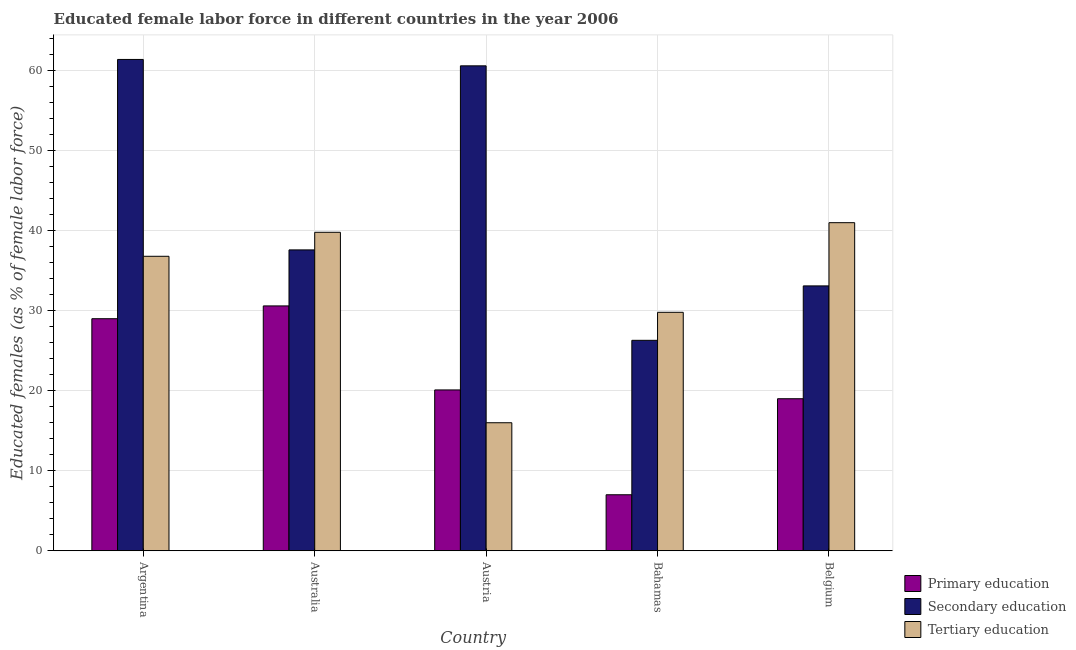How many different coloured bars are there?
Offer a very short reply. 3. Are the number of bars per tick equal to the number of legend labels?
Your answer should be compact. Yes. Are the number of bars on each tick of the X-axis equal?
Provide a short and direct response. Yes. How many bars are there on the 3rd tick from the left?
Your response must be concise. 3. How many bars are there on the 4th tick from the right?
Provide a short and direct response. 3. What is the label of the 5th group of bars from the left?
Provide a short and direct response. Belgium. In how many cases, is the number of bars for a given country not equal to the number of legend labels?
Your answer should be compact. 0. What is the percentage of female labor force who received primary education in Belgium?
Your answer should be compact. 19. Across all countries, what is the minimum percentage of female labor force who received tertiary education?
Provide a succinct answer. 16. In which country was the percentage of female labor force who received primary education maximum?
Make the answer very short. Australia. In which country was the percentage of female labor force who received secondary education minimum?
Provide a succinct answer. Bahamas. What is the total percentage of female labor force who received tertiary education in the graph?
Your answer should be very brief. 163.4. What is the difference between the percentage of female labor force who received secondary education in Bahamas and that in Belgium?
Keep it short and to the point. -6.8. What is the difference between the percentage of female labor force who received tertiary education in Bahamas and the percentage of female labor force who received primary education in Austria?
Provide a short and direct response. 9.7. What is the average percentage of female labor force who received tertiary education per country?
Provide a short and direct response. 32.68. What is the difference between the percentage of female labor force who received primary education and percentage of female labor force who received tertiary education in Argentina?
Your answer should be compact. -7.8. In how many countries, is the percentage of female labor force who received secondary education greater than 46 %?
Keep it short and to the point. 2. What is the ratio of the percentage of female labor force who received secondary education in Argentina to that in Austria?
Your answer should be very brief. 1.01. What is the difference between the highest and the second highest percentage of female labor force who received primary education?
Ensure brevity in your answer.  1.6. What is the difference between the highest and the lowest percentage of female labor force who received secondary education?
Make the answer very short. 35.1. Is the sum of the percentage of female labor force who received tertiary education in Austria and Belgium greater than the maximum percentage of female labor force who received secondary education across all countries?
Provide a short and direct response. No. How many bars are there?
Keep it short and to the point. 15. How many countries are there in the graph?
Ensure brevity in your answer.  5. Are the values on the major ticks of Y-axis written in scientific E-notation?
Offer a very short reply. No. Does the graph contain grids?
Keep it short and to the point. Yes. Where does the legend appear in the graph?
Give a very brief answer. Bottom right. How are the legend labels stacked?
Offer a very short reply. Vertical. What is the title of the graph?
Ensure brevity in your answer.  Educated female labor force in different countries in the year 2006. Does "Poland" appear as one of the legend labels in the graph?
Your answer should be compact. No. What is the label or title of the Y-axis?
Provide a succinct answer. Educated females (as % of female labor force). What is the Educated females (as % of female labor force) of Primary education in Argentina?
Your answer should be very brief. 29. What is the Educated females (as % of female labor force) in Secondary education in Argentina?
Offer a very short reply. 61.4. What is the Educated females (as % of female labor force) in Tertiary education in Argentina?
Keep it short and to the point. 36.8. What is the Educated females (as % of female labor force) in Primary education in Australia?
Provide a succinct answer. 30.6. What is the Educated females (as % of female labor force) in Secondary education in Australia?
Your response must be concise. 37.6. What is the Educated females (as % of female labor force) of Tertiary education in Australia?
Make the answer very short. 39.8. What is the Educated females (as % of female labor force) of Primary education in Austria?
Offer a very short reply. 20.1. What is the Educated females (as % of female labor force) of Secondary education in Austria?
Keep it short and to the point. 60.6. What is the Educated females (as % of female labor force) of Secondary education in Bahamas?
Keep it short and to the point. 26.3. What is the Educated females (as % of female labor force) of Tertiary education in Bahamas?
Provide a short and direct response. 29.8. What is the Educated females (as % of female labor force) in Primary education in Belgium?
Provide a succinct answer. 19. What is the Educated females (as % of female labor force) in Secondary education in Belgium?
Provide a short and direct response. 33.1. Across all countries, what is the maximum Educated females (as % of female labor force) of Primary education?
Your answer should be compact. 30.6. Across all countries, what is the maximum Educated females (as % of female labor force) of Secondary education?
Offer a terse response. 61.4. Across all countries, what is the maximum Educated females (as % of female labor force) of Tertiary education?
Give a very brief answer. 41. Across all countries, what is the minimum Educated females (as % of female labor force) of Secondary education?
Provide a short and direct response. 26.3. Across all countries, what is the minimum Educated females (as % of female labor force) in Tertiary education?
Offer a terse response. 16. What is the total Educated females (as % of female labor force) in Primary education in the graph?
Keep it short and to the point. 105.7. What is the total Educated females (as % of female labor force) of Secondary education in the graph?
Ensure brevity in your answer.  219. What is the total Educated females (as % of female labor force) in Tertiary education in the graph?
Keep it short and to the point. 163.4. What is the difference between the Educated females (as % of female labor force) in Primary education in Argentina and that in Australia?
Make the answer very short. -1.6. What is the difference between the Educated females (as % of female labor force) in Secondary education in Argentina and that in Australia?
Your answer should be very brief. 23.8. What is the difference between the Educated females (as % of female labor force) of Primary education in Argentina and that in Austria?
Make the answer very short. 8.9. What is the difference between the Educated females (as % of female labor force) in Secondary education in Argentina and that in Austria?
Ensure brevity in your answer.  0.8. What is the difference between the Educated females (as % of female labor force) of Tertiary education in Argentina and that in Austria?
Offer a very short reply. 20.8. What is the difference between the Educated females (as % of female labor force) of Secondary education in Argentina and that in Bahamas?
Your answer should be very brief. 35.1. What is the difference between the Educated females (as % of female labor force) of Tertiary education in Argentina and that in Bahamas?
Provide a short and direct response. 7. What is the difference between the Educated females (as % of female labor force) of Secondary education in Argentina and that in Belgium?
Your answer should be compact. 28.3. What is the difference between the Educated females (as % of female labor force) in Primary education in Australia and that in Austria?
Give a very brief answer. 10.5. What is the difference between the Educated females (as % of female labor force) in Secondary education in Australia and that in Austria?
Make the answer very short. -23. What is the difference between the Educated females (as % of female labor force) in Tertiary education in Australia and that in Austria?
Ensure brevity in your answer.  23.8. What is the difference between the Educated females (as % of female labor force) of Primary education in Australia and that in Bahamas?
Provide a short and direct response. 23.6. What is the difference between the Educated females (as % of female labor force) of Secondary education in Australia and that in Bahamas?
Provide a short and direct response. 11.3. What is the difference between the Educated females (as % of female labor force) in Tertiary education in Australia and that in Bahamas?
Give a very brief answer. 10. What is the difference between the Educated females (as % of female labor force) of Secondary education in Austria and that in Bahamas?
Offer a very short reply. 34.3. What is the difference between the Educated females (as % of female labor force) in Primary education in Austria and that in Belgium?
Keep it short and to the point. 1.1. What is the difference between the Educated females (as % of female labor force) of Tertiary education in Austria and that in Belgium?
Offer a terse response. -25. What is the difference between the Educated females (as % of female labor force) in Secondary education in Bahamas and that in Belgium?
Provide a succinct answer. -6.8. What is the difference between the Educated females (as % of female labor force) in Primary education in Argentina and the Educated females (as % of female labor force) in Secondary education in Australia?
Offer a very short reply. -8.6. What is the difference between the Educated females (as % of female labor force) of Primary education in Argentina and the Educated females (as % of female labor force) of Tertiary education in Australia?
Offer a terse response. -10.8. What is the difference between the Educated females (as % of female labor force) in Secondary education in Argentina and the Educated females (as % of female labor force) in Tertiary education in Australia?
Offer a very short reply. 21.6. What is the difference between the Educated females (as % of female labor force) of Primary education in Argentina and the Educated females (as % of female labor force) of Secondary education in Austria?
Give a very brief answer. -31.6. What is the difference between the Educated females (as % of female labor force) in Primary education in Argentina and the Educated females (as % of female labor force) in Tertiary education in Austria?
Keep it short and to the point. 13. What is the difference between the Educated females (as % of female labor force) in Secondary education in Argentina and the Educated females (as % of female labor force) in Tertiary education in Austria?
Make the answer very short. 45.4. What is the difference between the Educated females (as % of female labor force) of Primary education in Argentina and the Educated females (as % of female labor force) of Secondary education in Bahamas?
Offer a terse response. 2.7. What is the difference between the Educated females (as % of female labor force) in Primary education in Argentina and the Educated females (as % of female labor force) in Tertiary education in Bahamas?
Give a very brief answer. -0.8. What is the difference between the Educated females (as % of female labor force) of Secondary education in Argentina and the Educated females (as % of female labor force) of Tertiary education in Bahamas?
Your answer should be compact. 31.6. What is the difference between the Educated females (as % of female labor force) in Primary education in Argentina and the Educated females (as % of female labor force) in Secondary education in Belgium?
Give a very brief answer. -4.1. What is the difference between the Educated females (as % of female labor force) in Secondary education in Argentina and the Educated females (as % of female labor force) in Tertiary education in Belgium?
Provide a succinct answer. 20.4. What is the difference between the Educated females (as % of female labor force) of Secondary education in Australia and the Educated females (as % of female labor force) of Tertiary education in Austria?
Offer a very short reply. 21.6. What is the difference between the Educated females (as % of female labor force) in Primary education in Australia and the Educated females (as % of female labor force) in Secondary education in Bahamas?
Offer a terse response. 4.3. What is the difference between the Educated females (as % of female labor force) in Primary education in Australia and the Educated females (as % of female labor force) in Tertiary education in Belgium?
Your answer should be compact. -10.4. What is the difference between the Educated females (as % of female labor force) in Secondary education in Australia and the Educated females (as % of female labor force) in Tertiary education in Belgium?
Give a very brief answer. -3.4. What is the difference between the Educated females (as % of female labor force) of Secondary education in Austria and the Educated females (as % of female labor force) of Tertiary education in Bahamas?
Your answer should be very brief. 30.8. What is the difference between the Educated females (as % of female labor force) in Primary education in Austria and the Educated females (as % of female labor force) in Tertiary education in Belgium?
Ensure brevity in your answer.  -20.9. What is the difference between the Educated females (as % of female labor force) in Secondary education in Austria and the Educated females (as % of female labor force) in Tertiary education in Belgium?
Make the answer very short. 19.6. What is the difference between the Educated females (as % of female labor force) in Primary education in Bahamas and the Educated females (as % of female labor force) in Secondary education in Belgium?
Your answer should be compact. -26.1. What is the difference between the Educated females (as % of female labor force) in Primary education in Bahamas and the Educated females (as % of female labor force) in Tertiary education in Belgium?
Your answer should be compact. -34. What is the difference between the Educated females (as % of female labor force) of Secondary education in Bahamas and the Educated females (as % of female labor force) of Tertiary education in Belgium?
Your answer should be very brief. -14.7. What is the average Educated females (as % of female labor force) in Primary education per country?
Offer a terse response. 21.14. What is the average Educated females (as % of female labor force) of Secondary education per country?
Your answer should be very brief. 43.8. What is the average Educated females (as % of female labor force) in Tertiary education per country?
Your answer should be very brief. 32.68. What is the difference between the Educated females (as % of female labor force) in Primary education and Educated females (as % of female labor force) in Secondary education in Argentina?
Your response must be concise. -32.4. What is the difference between the Educated females (as % of female labor force) of Secondary education and Educated females (as % of female labor force) of Tertiary education in Argentina?
Provide a short and direct response. 24.6. What is the difference between the Educated females (as % of female labor force) of Primary education and Educated females (as % of female labor force) of Tertiary education in Australia?
Ensure brevity in your answer.  -9.2. What is the difference between the Educated females (as % of female labor force) in Primary education and Educated females (as % of female labor force) in Secondary education in Austria?
Your response must be concise. -40.5. What is the difference between the Educated females (as % of female labor force) of Secondary education and Educated females (as % of female labor force) of Tertiary education in Austria?
Your answer should be very brief. 44.6. What is the difference between the Educated females (as % of female labor force) of Primary education and Educated females (as % of female labor force) of Secondary education in Bahamas?
Your answer should be compact. -19.3. What is the difference between the Educated females (as % of female labor force) in Primary education and Educated females (as % of female labor force) in Tertiary education in Bahamas?
Give a very brief answer. -22.8. What is the difference between the Educated females (as % of female labor force) of Secondary education and Educated females (as % of female labor force) of Tertiary education in Bahamas?
Keep it short and to the point. -3.5. What is the difference between the Educated females (as % of female labor force) in Primary education and Educated females (as % of female labor force) in Secondary education in Belgium?
Your answer should be compact. -14.1. What is the ratio of the Educated females (as % of female labor force) in Primary education in Argentina to that in Australia?
Provide a short and direct response. 0.95. What is the ratio of the Educated females (as % of female labor force) of Secondary education in Argentina to that in Australia?
Offer a terse response. 1.63. What is the ratio of the Educated females (as % of female labor force) of Tertiary education in Argentina to that in Australia?
Provide a short and direct response. 0.92. What is the ratio of the Educated females (as % of female labor force) of Primary education in Argentina to that in Austria?
Offer a very short reply. 1.44. What is the ratio of the Educated females (as % of female labor force) in Secondary education in Argentina to that in Austria?
Ensure brevity in your answer.  1.01. What is the ratio of the Educated females (as % of female labor force) of Tertiary education in Argentina to that in Austria?
Make the answer very short. 2.3. What is the ratio of the Educated females (as % of female labor force) of Primary education in Argentina to that in Bahamas?
Ensure brevity in your answer.  4.14. What is the ratio of the Educated females (as % of female labor force) in Secondary education in Argentina to that in Bahamas?
Provide a succinct answer. 2.33. What is the ratio of the Educated females (as % of female labor force) in Tertiary education in Argentina to that in Bahamas?
Make the answer very short. 1.23. What is the ratio of the Educated females (as % of female labor force) of Primary education in Argentina to that in Belgium?
Your answer should be very brief. 1.53. What is the ratio of the Educated females (as % of female labor force) of Secondary education in Argentina to that in Belgium?
Your answer should be very brief. 1.85. What is the ratio of the Educated females (as % of female labor force) in Tertiary education in Argentina to that in Belgium?
Your answer should be very brief. 0.9. What is the ratio of the Educated females (as % of female labor force) of Primary education in Australia to that in Austria?
Make the answer very short. 1.52. What is the ratio of the Educated females (as % of female labor force) of Secondary education in Australia to that in Austria?
Provide a succinct answer. 0.62. What is the ratio of the Educated females (as % of female labor force) in Tertiary education in Australia to that in Austria?
Give a very brief answer. 2.49. What is the ratio of the Educated females (as % of female labor force) in Primary education in Australia to that in Bahamas?
Provide a succinct answer. 4.37. What is the ratio of the Educated females (as % of female labor force) of Secondary education in Australia to that in Bahamas?
Your response must be concise. 1.43. What is the ratio of the Educated females (as % of female labor force) in Tertiary education in Australia to that in Bahamas?
Your response must be concise. 1.34. What is the ratio of the Educated females (as % of female labor force) in Primary education in Australia to that in Belgium?
Keep it short and to the point. 1.61. What is the ratio of the Educated females (as % of female labor force) in Secondary education in Australia to that in Belgium?
Offer a terse response. 1.14. What is the ratio of the Educated females (as % of female labor force) in Tertiary education in Australia to that in Belgium?
Give a very brief answer. 0.97. What is the ratio of the Educated females (as % of female labor force) of Primary education in Austria to that in Bahamas?
Give a very brief answer. 2.87. What is the ratio of the Educated females (as % of female labor force) of Secondary education in Austria to that in Bahamas?
Make the answer very short. 2.3. What is the ratio of the Educated females (as % of female labor force) of Tertiary education in Austria to that in Bahamas?
Make the answer very short. 0.54. What is the ratio of the Educated females (as % of female labor force) of Primary education in Austria to that in Belgium?
Make the answer very short. 1.06. What is the ratio of the Educated females (as % of female labor force) of Secondary education in Austria to that in Belgium?
Your response must be concise. 1.83. What is the ratio of the Educated females (as % of female labor force) of Tertiary education in Austria to that in Belgium?
Your answer should be compact. 0.39. What is the ratio of the Educated females (as % of female labor force) of Primary education in Bahamas to that in Belgium?
Provide a short and direct response. 0.37. What is the ratio of the Educated females (as % of female labor force) of Secondary education in Bahamas to that in Belgium?
Offer a very short reply. 0.79. What is the ratio of the Educated females (as % of female labor force) in Tertiary education in Bahamas to that in Belgium?
Keep it short and to the point. 0.73. What is the difference between the highest and the second highest Educated females (as % of female labor force) of Secondary education?
Provide a succinct answer. 0.8. What is the difference between the highest and the second highest Educated females (as % of female labor force) of Tertiary education?
Your answer should be compact. 1.2. What is the difference between the highest and the lowest Educated females (as % of female labor force) in Primary education?
Offer a very short reply. 23.6. What is the difference between the highest and the lowest Educated females (as % of female labor force) of Secondary education?
Give a very brief answer. 35.1. What is the difference between the highest and the lowest Educated females (as % of female labor force) of Tertiary education?
Give a very brief answer. 25. 